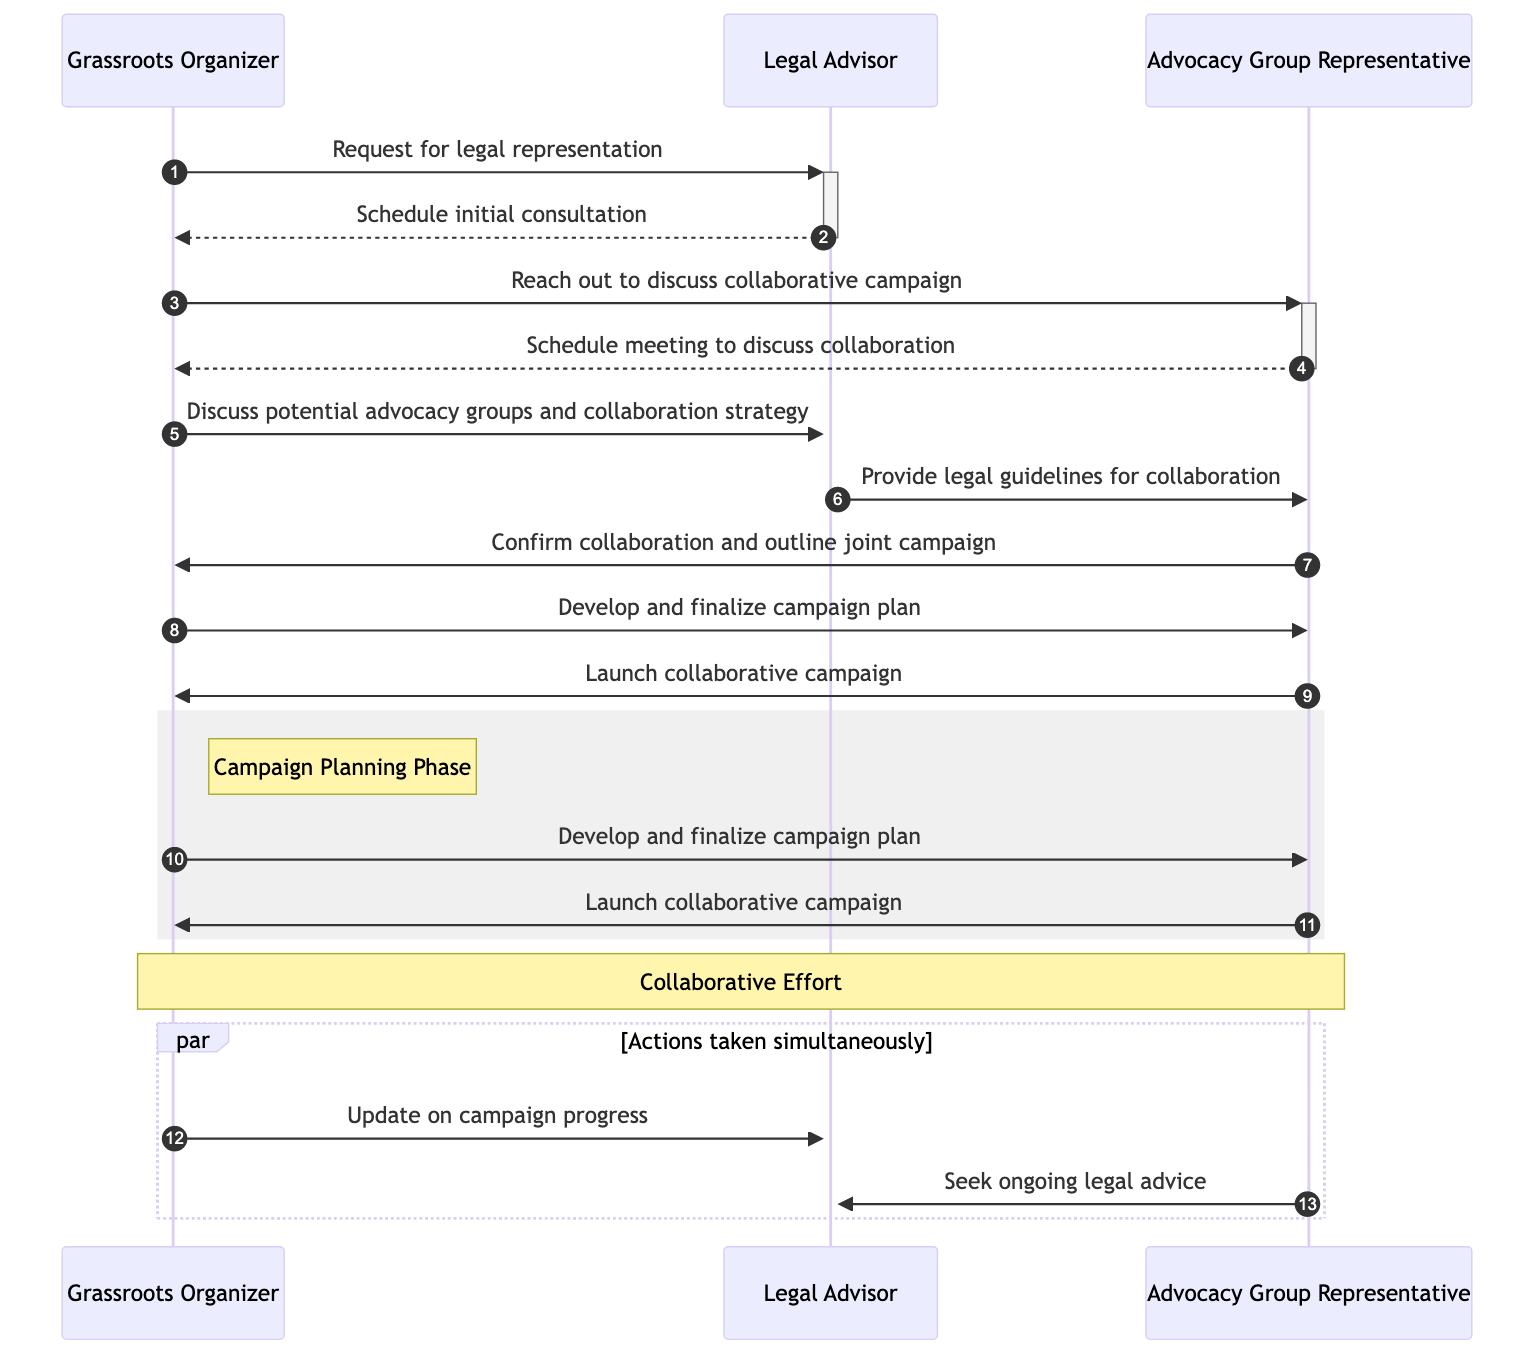What is the first action performed by the Grassroots Organizer? The first action shown in the diagram is sending a request for legal representation to the Legal Advisor. This initiates the sequence of interactions between the participants.
Answer: Request for legal representation How many main actors are present in the diagram? The diagram includes three main actors: Grassroots Organizer, Legal Advisor, and Advocacy Group Representative. Each actor plays a distinct role in the sequence of events.
Answer: Three What action does the Advocacy Group Representative take after confirming collaboration? After confirming collaboration, the Advocacy Group Representative outlines the joint campaign to the Grassroots Organizer, detailing the collaborative efforts agreed upon.
Answer: Outline joint campaign Which two actions occur simultaneously in the diagram? The Grassroots Organizer updates the Legal Advisor on campaign progress while the Advocacy Group Representative seeks ongoing legal advice from the Legal Advisor. These two interactions happen at the same time, as indicated by the parallel section of the diagram.
Answer: Update on campaign progress and seek ongoing legal advice Who sends the legal guidelines for collaboration? The Legal Advisor is responsible for sending the legal guidelines for collaboration to the Advocacy Group Representative. This exchange is crucial for establishing a framework within which the parties can work together legally.
Answer: Legal Advisor 